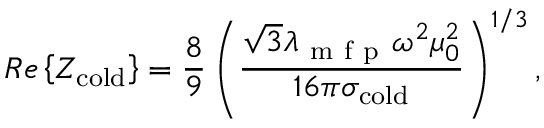<formula> <loc_0><loc_0><loc_500><loc_500>R e \left \{ Z _ { c o l d } \right \} = \frac { 8 } { 9 } \left ( \frac { \sqrt { 3 } \lambda _ { m f p } \omega ^ { 2 } \mu _ { 0 } ^ { 2 } } { 1 6 \pi \sigma _ { c o l d } } \right ) ^ { 1 / 3 } ,</formula> 